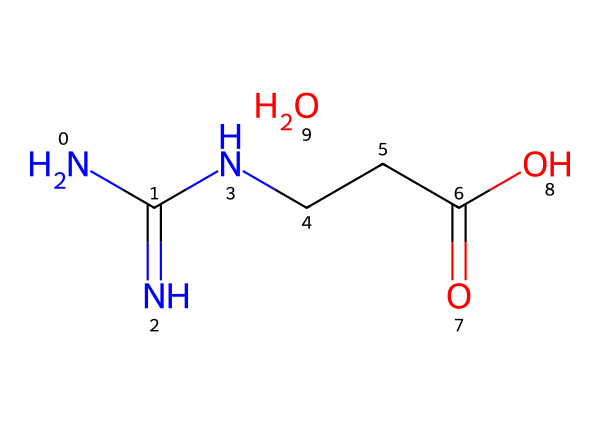What is the common name for the chemical represented? The SMILES representation indicates a structure with nitrogen and carbon, corresponding to creatine monohydrate, a known sports supplement.
Answer: creatine monohydrate How many nitrogen atoms are present in the structure? Analyzing the SMILES, there are two nitrogen atoms indicated by 'N' in the formula.
Answer: two What functional groups are present in creatine monohydrate? The SMILES shows a carboxylic acid functional group (C(=O)O) and an amine group (N) attached to the carbon chain, typical for amino acids and supplements.
Answer: carboxylic acid, amine What is the molecular weight of creatine monohydrate approximately? Calculating from the atomic weights in the structure, the approximate molecular weight of creatine monohydrate is about 149 grams per mole.
Answer: 149 Which part of the molecule contributes to its solubility in water? The presence of the hydroxyl group (from the carboxylic acid) aids in water solubility due to hydrogen bonding with water molecules.
Answer: hydroxyl group How many carbon atoms are there in the chemical structure? Looking at the SMILES notation, there are three carbon atoms represented in the structure (C, CCC).
Answer: three 